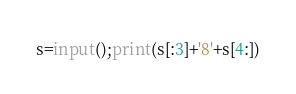Convert code to text. <code><loc_0><loc_0><loc_500><loc_500><_Python_>s=input();print(s[:3]+'8'+s[4:])
</code> 